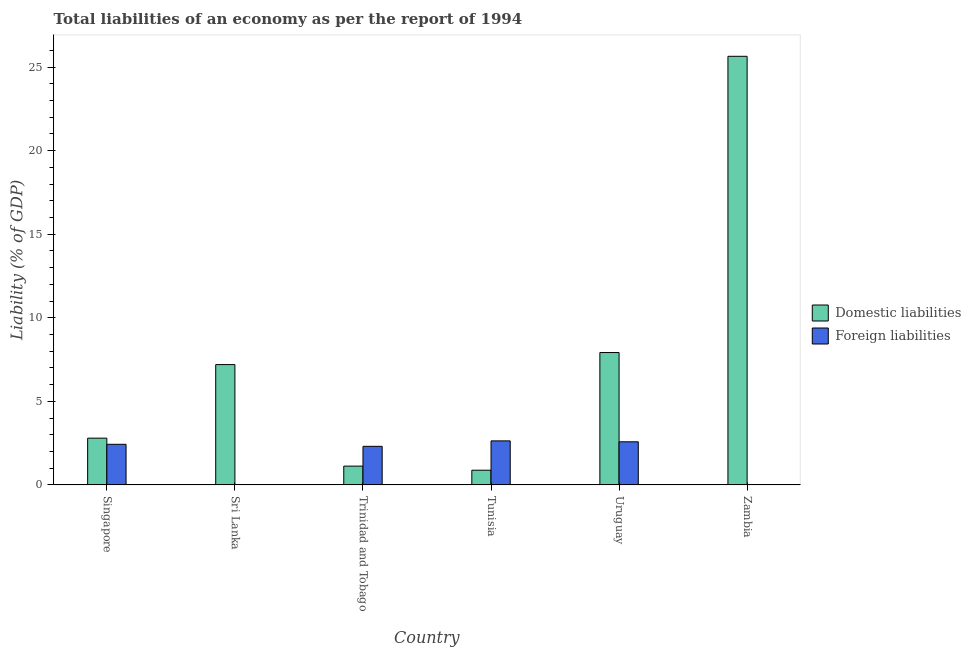Are the number of bars per tick equal to the number of legend labels?
Your response must be concise. No. How many bars are there on the 3rd tick from the right?
Offer a terse response. 2. What is the label of the 4th group of bars from the left?
Your answer should be very brief. Tunisia. What is the incurrence of foreign liabilities in Uruguay?
Your answer should be very brief. 2.58. Across all countries, what is the maximum incurrence of domestic liabilities?
Ensure brevity in your answer.  25.65. Across all countries, what is the minimum incurrence of domestic liabilities?
Give a very brief answer. 0.88. In which country was the incurrence of domestic liabilities maximum?
Make the answer very short. Zambia. What is the total incurrence of foreign liabilities in the graph?
Offer a terse response. 9.95. What is the difference between the incurrence of domestic liabilities in Sri Lanka and that in Zambia?
Offer a terse response. -18.45. What is the difference between the incurrence of domestic liabilities in Sri Lanka and the incurrence of foreign liabilities in Singapore?
Offer a very short reply. 4.77. What is the average incurrence of foreign liabilities per country?
Make the answer very short. 1.66. What is the difference between the incurrence of domestic liabilities and incurrence of foreign liabilities in Tunisia?
Give a very brief answer. -1.75. In how many countries, is the incurrence of foreign liabilities greater than 15 %?
Your answer should be very brief. 0. What is the ratio of the incurrence of domestic liabilities in Sri Lanka to that in Trinidad and Tobago?
Provide a succinct answer. 6.41. Is the incurrence of foreign liabilities in Trinidad and Tobago less than that in Tunisia?
Offer a terse response. Yes. What is the difference between the highest and the second highest incurrence of domestic liabilities?
Provide a short and direct response. 17.73. What is the difference between the highest and the lowest incurrence of foreign liabilities?
Your answer should be compact. 2.63. In how many countries, is the incurrence of foreign liabilities greater than the average incurrence of foreign liabilities taken over all countries?
Your answer should be compact. 4. Is the sum of the incurrence of domestic liabilities in Singapore and Uruguay greater than the maximum incurrence of foreign liabilities across all countries?
Ensure brevity in your answer.  Yes. What is the difference between two consecutive major ticks on the Y-axis?
Your answer should be very brief. 5. Does the graph contain grids?
Keep it short and to the point. No. Where does the legend appear in the graph?
Your answer should be very brief. Center right. How many legend labels are there?
Make the answer very short. 2. What is the title of the graph?
Provide a succinct answer. Total liabilities of an economy as per the report of 1994. Does "Mineral" appear as one of the legend labels in the graph?
Offer a very short reply. No. What is the label or title of the X-axis?
Your answer should be very brief. Country. What is the label or title of the Y-axis?
Your response must be concise. Liability (% of GDP). What is the Liability (% of GDP) in Domestic liabilities in Singapore?
Keep it short and to the point. 2.8. What is the Liability (% of GDP) in Foreign liabilities in Singapore?
Your answer should be very brief. 2.43. What is the Liability (% of GDP) in Domestic liabilities in Sri Lanka?
Keep it short and to the point. 7.2. What is the Liability (% of GDP) of Domestic liabilities in Trinidad and Tobago?
Make the answer very short. 1.12. What is the Liability (% of GDP) in Foreign liabilities in Trinidad and Tobago?
Ensure brevity in your answer.  2.31. What is the Liability (% of GDP) of Domestic liabilities in Tunisia?
Offer a terse response. 0.88. What is the Liability (% of GDP) in Foreign liabilities in Tunisia?
Provide a succinct answer. 2.63. What is the Liability (% of GDP) of Domestic liabilities in Uruguay?
Your response must be concise. 7.92. What is the Liability (% of GDP) in Foreign liabilities in Uruguay?
Ensure brevity in your answer.  2.58. What is the Liability (% of GDP) in Domestic liabilities in Zambia?
Ensure brevity in your answer.  25.65. What is the Liability (% of GDP) in Foreign liabilities in Zambia?
Make the answer very short. 0. Across all countries, what is the maximum Liability (% of GDP) in Domestic liabilities?
Make the answer very short. 25.65. Across all countries, what is the maximum Liability (% of GDP) of Foreign liabilities?
Provide a short and direct response. 2.63. Across all countries, what is the minimum Liability (% of GDP) of Domestic liabilities?
Your response must be concise. 0.88. Across all countries, what is the minimum Liability (% of GDP) in Foreign liabilities?
Your answer should be compact. 0. What is the total Liability (% of GDP) of Domestic liabilities in the graph?
Offer a terse response. 45.57. What is the total Liability (% of GDP) in Foreign liabilities in the graph?
Your response must be concise. 9.95. What is the difference between the Liability (% of GDP) of Domestic liabilities in Singapore and that in Sri Lanka?
Keep it short and to the point. -4.4. What is the difference between the Liability (% of GDP) of Domestic liabilities in Singapore and that in Trinidad and Tobago?
Give a very brief answer. 1.67. What is the difference between the Liability (% of GDP) of Foreign liabilities in Singapore and that in Trinidad and Tobago?
Your response must be concise. 0.12. What is the difference between the Liability (% of GDP) of Domestic liabilities in Singapore and that in Tunisia?
Keep it short and to the point. 1.92. What is the difference between the Liability (% of GDP) in Foreign liabilities in Singapore and that in Tunisia?
Offer a terse response. -0.2. What is the difference between the Liability (% of GDP) of Domestic liabilities in Singapore and that in Uruguay?
Give a very brief answer. -5.12. What is the difference between the Liability (% of GDP) of Foreign liabilities in Singapore and that in Uruguay?
Your response must be concise. -0.15. What is the difference between the Liability (% of GDP) of Domestic liabilities in Singapore and that in Zambia?
Provide a succinct answer. -22.85. What is the difference between the Liability (% of GDP) of Domestic liabilities in Sri Lanka and that in Trinidad and Tobago?
Ensure brevity in your answer.  6.08. What is the difference between the Liability (% of GDP) in Domestic liabilities in Sri Lanka and that in Tunisia?
Your answer should be compact. 6.32. What is the difference between the Liability (% of GDP) of Domestic liabilities in Sri Lanka and that in Uruguay?
Give a very brief answer. -0.72. What is the difference between the Liability (% of GDP) of Domestic liabilities in Sri Lanka and that in Zambia?
Your response must be concise. -18.45. What is the difference between the Liability (% of GDP) in Domestic liabilities in Trinidad and Tobago and that in Tunisia?
Your answer should be very brief. 0.24. What is the difference between the Liability (% of GDP) in Foreign liabilities in Trinidad and Tobago and that in Tunisia?
Offer a terse response. -0.33. What is the difference between the Liability (% of GDP) of Domestic liabilities in Trinidad and Tobago and that in Uruguay?
Give a very brief answer. -6.8. What is the difference between the Liability (% of GDP) of Foreign liabilities in Trinidad and Tobago and that in Uruguay?
Offer a very short reply. -0.27. What is the difference between the Liability (% of GDP) in Domestic liabilities in Trinidad and Tobago and that in Zambia?
Your answer should be very brief. -24.52. What is the difference between the Liability (% of GDP) in Domestic liabilities in Tunisia and that in Uruguay?
Make the answer very short. -7.04. What is the difference between the Liability (% of GDP) of Foreign liabilities in Tunisia and that in Uruguay?
Offer a terse response. 0.05. What is the difference between the Liability (% of GDP) in Domestic liabilities in Tunisia and that in Zambia?
Ensure brevity in your answer.  -24.77. What is the difference between the Liability (% of GDP) of Domestic liabilities in Uruguay and that in Zambia?
Your response must be concise. -17.73. What is the difference between the Liability (% of GDP) in Domestic liabilities in Singapore and the Liability (% of GDP) in Foreign liabilities in Trinidad and Tobago?
Provide a succinct answer. 0.49. What is the difference between the Liability (% of GDP) in Domestic liabilities in Singapore and the Liability (% of GDP) in Foreign liabilities in Tunisia?
Your answer should be compact. 0.16. What is the difference between the Liability (% of GDP) in Domestic liabilities in Singapore and the Liability (% of GDP) in Foreign liabilities in Uruguay?
Your answer should be very brief. 0.22. What is the difference between the Liability (% of GDP) of Domestic liabilities in Sri Lanka and the Liability (% of GDP) of Foreign liabilities in Trinidad and Tobago?
Provide a succinct answer. 4.89. What is the difference between the Liability (% of GDP) in Domestic liabilities in Sri Lanka and the Liability (% of GDP) in Foreign liabilities in Tunisia?
Keep it short and to the point. 4.57. What is the difference between the Liability (% of GDP) in Domestic liabilities in Sri Lanka and the Liability (% of GDP) in Foreign liabilities in Uruguay?
Offer a terse response. 4.62. What is the difference between the Liability (% of GDP) of Domestic liabilities in Trinidad and Tobago and the Liability (% of GDP) of Foreign liabilities in Tunisia?
Your answer should be very brief. -1.51. What is the difference between the Liability (% of GDP) in Domestic liabilities in Trinidad and Tobago and the Liability (% of GDP) in Foreign liabilities in Uruguay?
Offer a terse response. -1.46. What is the difference between the Liability (% of GDP) of Domestic liabilities in Tunisia and the Liability (% of GDP) of Foreign liabilities in Uruguay?
Offer a terse response. -1.7. What is the average Liability (% of GDP) of Domestic liabilities per country?
Offer a very short reply. 7.59. What is the average Liability (% of GDP) of Foreign liabilities per country?
Offer a very short reply. 1.66. What is the difference between the Liability (% of GDP) in Domestic liabilities and Liability (% of GDP) in Foreign liabilities in Singapore?
Ensure brevity in your answer.  0.37. What is the difference between the Liability (% of GDP) of Domestic liabilities and Liability (% of GDP) of Foreign liabilities in Trinidad and Tobago?
Your answer should be very brief. -1.18. What is the difference between the Liability (% of GDP) of Domestic liabilities and Liability (% of GDP) of Foreign liabilities in Tunisia?
Your response must be concise. -1.75. What is the difference between the Liability (% of GDP) in Domestic liabilities and Liability (% of GDP) in Foreign liabilities in Uruguay?
Your answer should be very brief. 5.34. What is the ratio of the Liability (% of GDP) in Domestic liabilities in Singapore to that in Sri Lanka?
Your answer should be very brief. 0.39. What is the ratio of the Liability (% of GDP) in Domestic liabilities in Singapore to that in Trinidad and Tobago?
Your answer should be very brief. 2.49. What is the ratio of the Liability (% of GDP) in Foreign liabilities in Singapore to that in Trinidad and Tobago?
Make the answer very short. 1.05. What is the ratio of the Liability (% of GDP) of Domestic liabilities in Singapore to that in Tunisia?
Ensure brevity in your answer.  3.18. What is the ratio of the Liability (% of GDP) of Foreign liabilities in Singapore to that in Tunisia?
Offer a very short reply. 0.92. What is the ratio of the Liability (% of GDP) of Domestic liabilities in Singapore to that in Uruguay?
Offer a very short reply. 0.35. What is the ratio of the Liability (% of GDP) of Foreign liabilities in Singapore to that in Uruguay?
Make the answer very short. 0.94. What is the ratio of the Liability (% of GDP) in Domestic liabilities in Singapore to that in Zambia?
Your answer should be compact. 0.11. What is the ratio of the Liability (% of GDP) in Domestic liabilities in Sri Lanka to that in Trinidad and Tobago?
Offer a terse response. 6.41. What is the ratio of the Liability (% of GDP) in Domestic liabilities in Sri Lanka to that in Tunisia?
Keep it short and to the point. 8.19. What is the ratio of the Liability (% of GDP) in Domestic liabilities in Sri Lanka to that in Uruguay?
Offer a terse response. 0.91. What is the ratio of the Liability (% of GDP) of Domestic liabilities in Sri Lanka to that in Zambia?
Provide a short and direct response. 0.28. What is the ratio of the Liability (% of GDP) in Domestic liabilities in Trinidad and Tobago to that in Tunisia?
Give a very brief answer. 1.28. What is the ratio of the Liability (% of GDP) in Foreign liabilities in Trinidad and Tobago to that in Tunisia?
Ensure brevity in your answer.  0.88. What is the ratio of the Liability (% of GDP) of Domestic liabilities in Trinidad and Tobago to that in Uruguay?
Your answer should be very brief. 0.14. What is the ratio of the Liability (% of GDP) of Foreign liabilities in Trinidad and Tobago to that in Uruguay?
Keep it short and to the point. 0.89. What is the ratio of the Liability (% of GDP) in Domestic liabilities in Trinidad and Tobago to that in Zambia?
Your response must be concise. 0.04. What is the ratio of the Liability (% of GDP) in Domestic liabilities in Tunisia to that in Uruguay?
Your answer should be compact. 0.11. What is the ratio of the Liability (% of GDP) of Foreign liabilities in Tunisia to that in Uruguay?
Your answer should be compact. 1.02. What is the ratio of the Liability (% of GDP) in Domestic liabilities in Tunisia to that in Zambia?
Make the answer very short. 0.03. What is the ratio of the Liability (% of GDP) of Domestic liabilities in Uruguay to that in Zambia?
Your answer should be very brief. 0.31. What is the difference between the highest and the second highest Liability (% of GDP) of Domestic liabilities?
Keep it short and to the point. 17.73. What is the difference between the highest and the second highest Liability (% of GDP) in Foreign liabilities?
Your answer should be compact. 0.05. What is the difference between the highest and the lowest Liability (% of GDP) in Domestic liabilities?
Your answer should be compact. 24.77. What is the difference between the highest and the lowest Liability (% of GDP) of Foreign liabilities?
Your answer should be very brief. 2.63. 